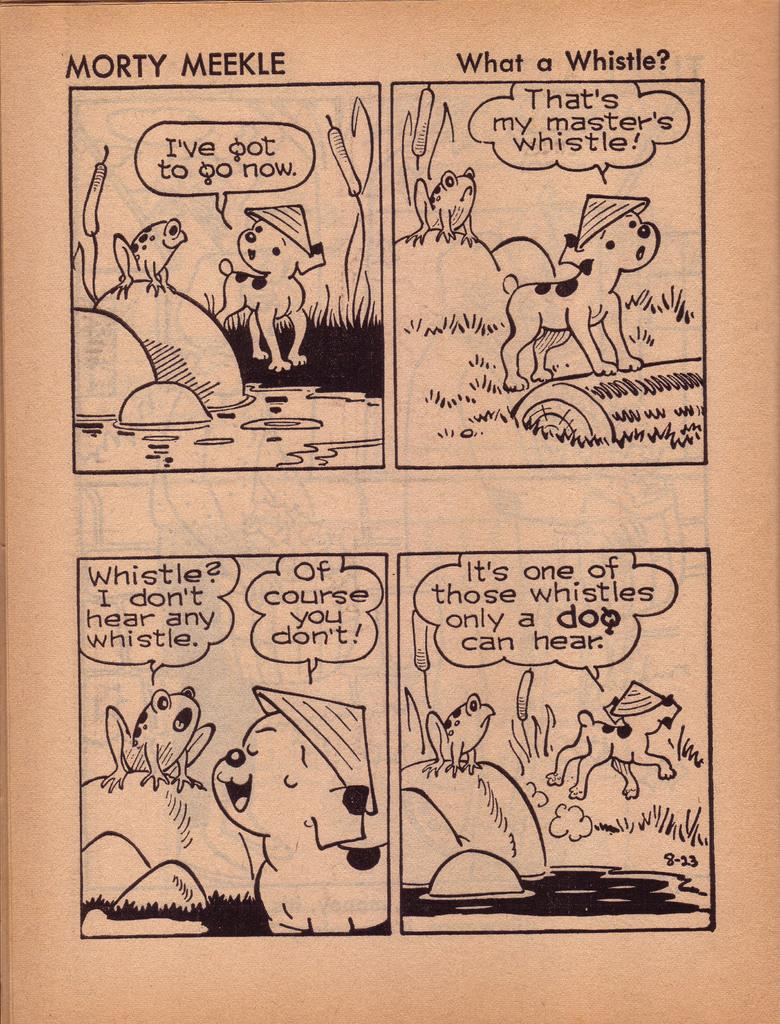<image>
Give a short and clear explanation of the subsequent image. a Morty Meekle comic strip that appears to be very vintage. 